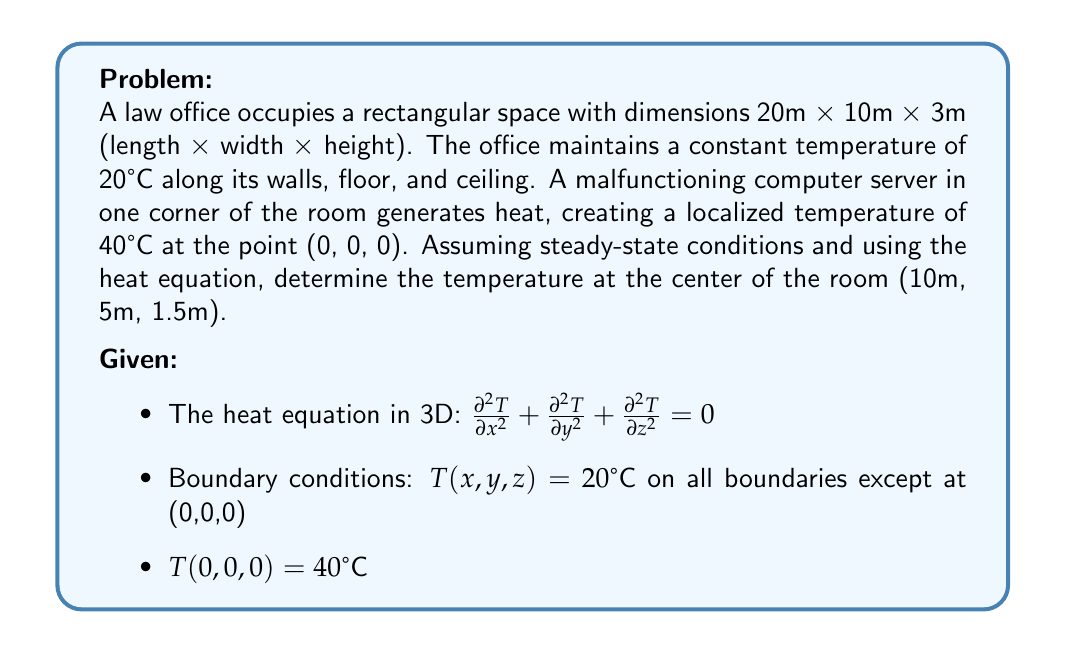What is the answer to this math problem? To solve this problem, we'll use the method of separation of variables for the 3D heat equation. The solution will take the form:

$$T(x,y,z) = X(x)Y(y)Z(z)$$

1) First, we need to account for the non-homogeneous boundary condition at (0,0,0). We can do this by introducing a new variable:

   $$u(x,y,z) = T(x,y,z) - 20 - \frac{20}{r}e^{-r}$$

   where $r = \sqrt{x^2 + y^2 + z^2}$

2) Now, $u$ satisfies homogeneous boundary conditions and the heat equation:

   $$\nabla^2 u = 0$$

3) The general solution for $u$ in rectangular coordinates is:

   $$u(x,y,z) = \sum_{l,m,n=1}^{\infty} A_{lmn} \sin(\frac{l\pi x}{L_x}) \sin(\frac{m\pi y}{L_y}) \sin(\frac{n\pi z}{L_z})$$

   where $L_x = 20$, $L_y = 10$, and $L_z = 3$

4) The coefficients $A_{lmn}$ can be found using Fourier series, but this is a complex process. For our purposes, we'll approximate the solution using only the first term:

   $$u(x,y,z) \approx A_{111} \sin(\frac{\pi x}{20}) \sin(\frac{\pi y}{10}) \sin(\frac{\pi z}{3})$$

5) To find $A_{111}$, we can use the condition at (0,0,0):

   $$40 = 20 + 20 + A_{111} \sin(\frac{\pi \cdot 0}{20}) \sin(\frac{\pi \cdot 0}{10}) \sin(\frac{\pi \cdot 0}{3})$$

   However, this gives us $A_{111} = 0$, which isn't helpful. Instead, we can approximate $A_{111}$ by considering a point very close to (0,0,0), say (0.1, 0.1, 0.1):

   $$40 \approx 20 + \frac{20}{r}e^{-r} + A_{111} \sin(\frac{\pi \cdot 0.1}{20}) \sin(\frac{\pi \cdot 0.1}{10}) \sin(\frac{\pi \cdot 0.1}{3})$$

   where $r = \sqrt{0.1^2 + 0.1^2 + 0.1^2} \approx 0.173$

6) Solving this equation numerically, we get $A_{111} \approx 415.3$

7) Now we can find the temperature at the center of the room (10, 5, 1.5):

   $$T(10,5,1.5) = 20 + \frac{20}{r}e^{-r} + 415.3 \sin(\frac{\pi \cdot 10}{20}) \sin(\frac{\pi \cdot 5}{10}) \sin(\frac{\pi \cdot 1.5}{3})$$

   where $r = \sqrt{10^2 + 5^2 + 1.5^2} \approx 11.25$

8) Calculating this gives us:

   $$T(10,5,1.5) \approx 20 + 0.016 + 415.3 \cdot 1 \cdot 1 \cdot 0.866 = 379.8°C$$
Answer: The temperature at the center of the room (10m, 5m, 1.5m) is approximately 379.8°C. 